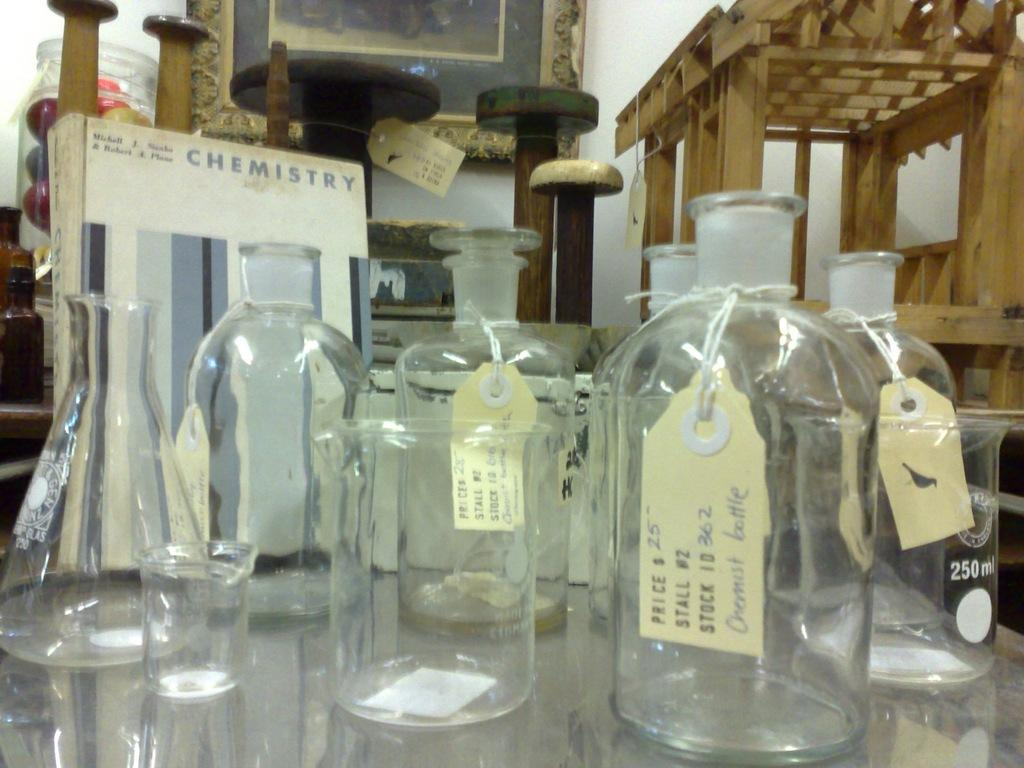<image>
Write a terse but informative summary of the picture. A group of decanters with labels and a Chemistry sign propped up. 